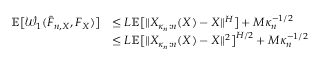Convert formula to latex. <formula><loc_0><loc_0><loc_500><loc_500>\begin{array} { r l } { \mathbb { E } \left [ \mathcal { W } _ { 1 } ( \hat { F } _ { n , X } , F _ { X } ) \right ] } & { \leq L \mathbb { E } \left [ \| X _ { \kappa _ { n } \colon n } ( X ) - X \| ^ { H } \right ] + M \kappa _ { n } ^ { - 1 / 2 } } \\ & { \leq L \mathbb { E } \left [ \| X _ { \kappa _ { n } \colon n } ( X ) - X \| ^ { 2 } \right ] ^ { H / 2 } + M \kappa _ { n } ^ { - 1 / 2 } } \end{array}</formula> 